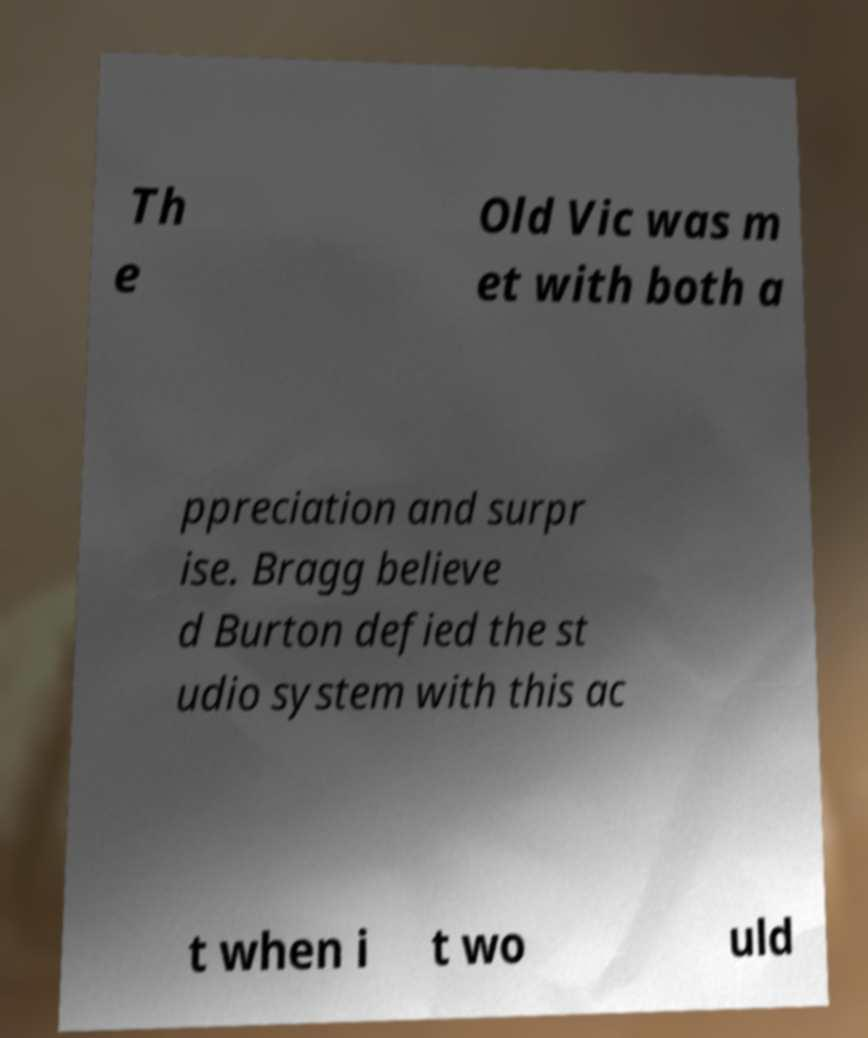Could you extract and type out the text from this image? Th e Old Vic was m et with both a ppreciation and surpr ise. Bragg believe d Burton defied the st udio system with this ac t when i t wo uld 